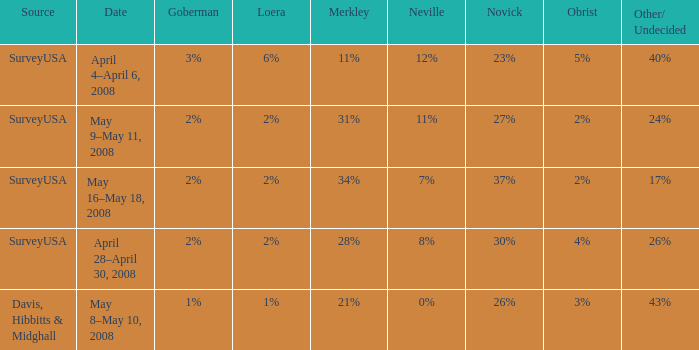Which Date has a Novick of 26%? May 8–May 10, 2008. 